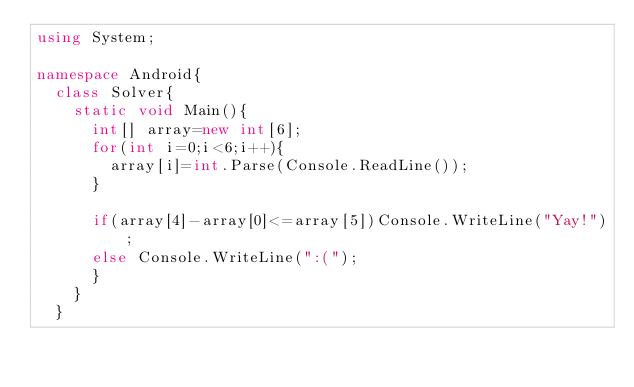<code> <loc_0><loc_0><loc_500><loc_500><_C#_>using System;

namespace Android{
  class Solver{
    static void Main(){
      int[] array=new int[6];
      for(int i=0;i<6;i++){
        array[i]=int.Parse(Console.ReadLine());
      }
      
      if(array[4]-array[0]<=array[5])Console.WriteLine("Yay!");
      else Console.WriteLine(":(");
      }
    }
  }</code> 